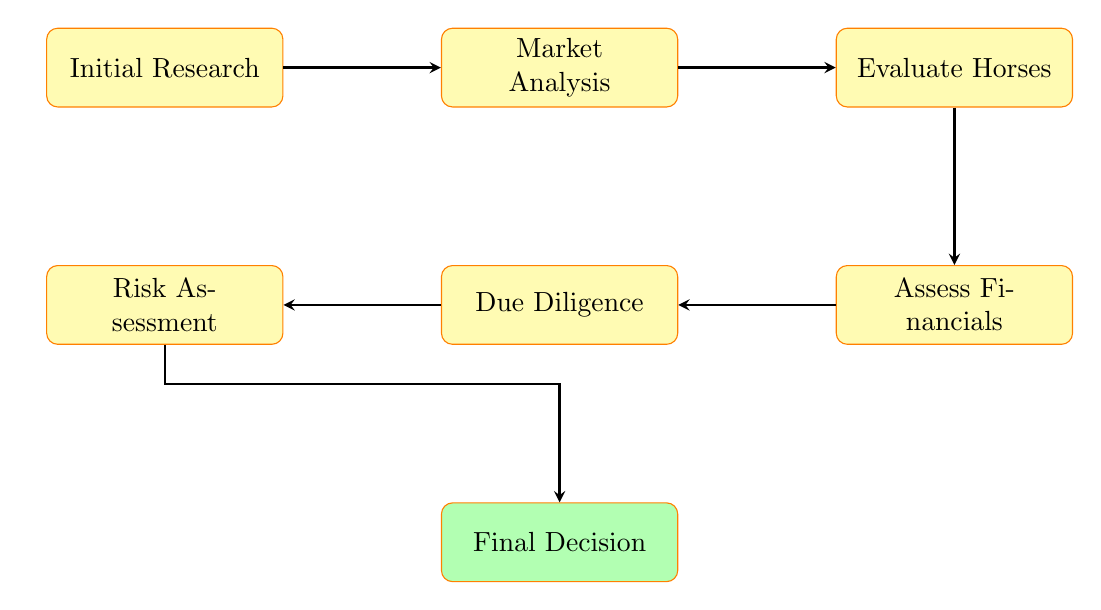What is the first step in the diagram? The diagram starts with the node labeled "Initial Research," which indicates the first step in evaluating a horse racing investment opportunity.
Answer: Initial Research How many nodes are present in the flow chart? Counting all the distinct labeled nodes in the diagram, there are six nodes: Initial Research, Market Analysis, Evaluate Horses, Assess Financials, Due Diligence, and Risk Assessment.
Answer: 6 What leads to "Final Decision"? The arrow leading to "Final Decision" comes from "Risk Assessment," indicating that this step must be completed before arriving at the final decision.
Answer: Risk Assessment Which node comes after "Market Analysis"? The diagram shows that after "Market Analysis," the flow goes to "Evaluate Horses," meaning that is the next step in the process.
Answer: Evaluate Horses What is the relationship between "Assess Financials" and "Due Diligence"? "Assess Financials" flows directly down to "Due Diligence," showing that evaluating financials is a prerequisite for conducting due diligence on the investment opportunity.
Answer: Assess Financials to Due Diligence What is the last step before reaching "Final Decision"? The last step before making the final decision in the diagram is the "Risk Assessment," which must be conducted prior to finalizing any investment.
Answer: Risk Assessment 